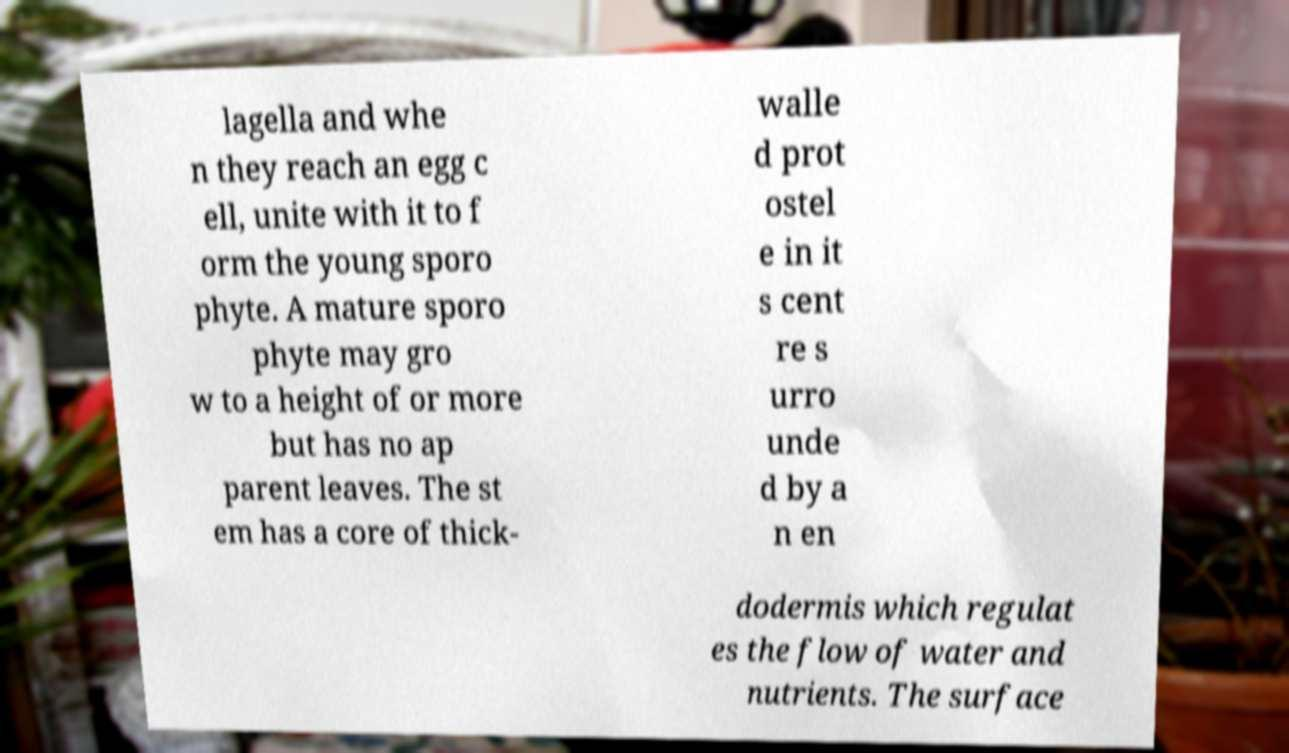Can you accurately transcribe the text from the provided image for me? lagella and whe n they reach an egg c ell, unite with it to f orm the young sporo phyte. A mature sporo phyte may gro w to a height of or more but has no ap parent leaves. The st em has a core of thick- walle d prot ostel e in it s cent re s urro unde d by a n en dodermis which regulat es the flow of water and nutrients. The surface 